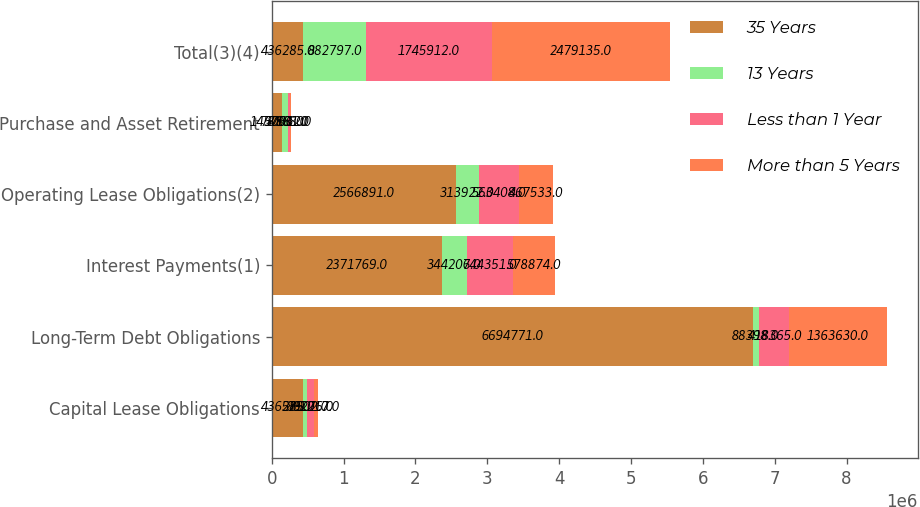Convert chart. <chart><loc_0><loc_0><loc_500><loc_500><stacked_bar_chart><ecel><fcel>Capital Lease Obligations<fcel>Long-Term Debt Obligations<fcel>Interest Payments(1)<fcel>Operating Lease Obligations(2)<fcel>Purchase and Asset Retirement<fcel>Total(3)(4)<nl><fcel>35 Years<fcel>436285<fcel>6.69477e+06<fcel>2.37177e+06<fcel>2.56689e+06<fcel>145706<fcel>436285<nl><fcel>13 Years<fcel>57902<fcel>88398<fcel>344207<fcel>313922<fcel>78368<fcel>882797<nl><fcel>Less than 1 Year<fcel>89276<fcel>418365<fcel>644351<fcel>563408<fcel>30512<fcel>1.74591e+06<nl><fcel>More than 5 Years<fcel>61217<fcel>1.36363e+06<fcel>578874<fcel>467533<fcel>7881<fcel>2.47914e+06<nl></chart> 